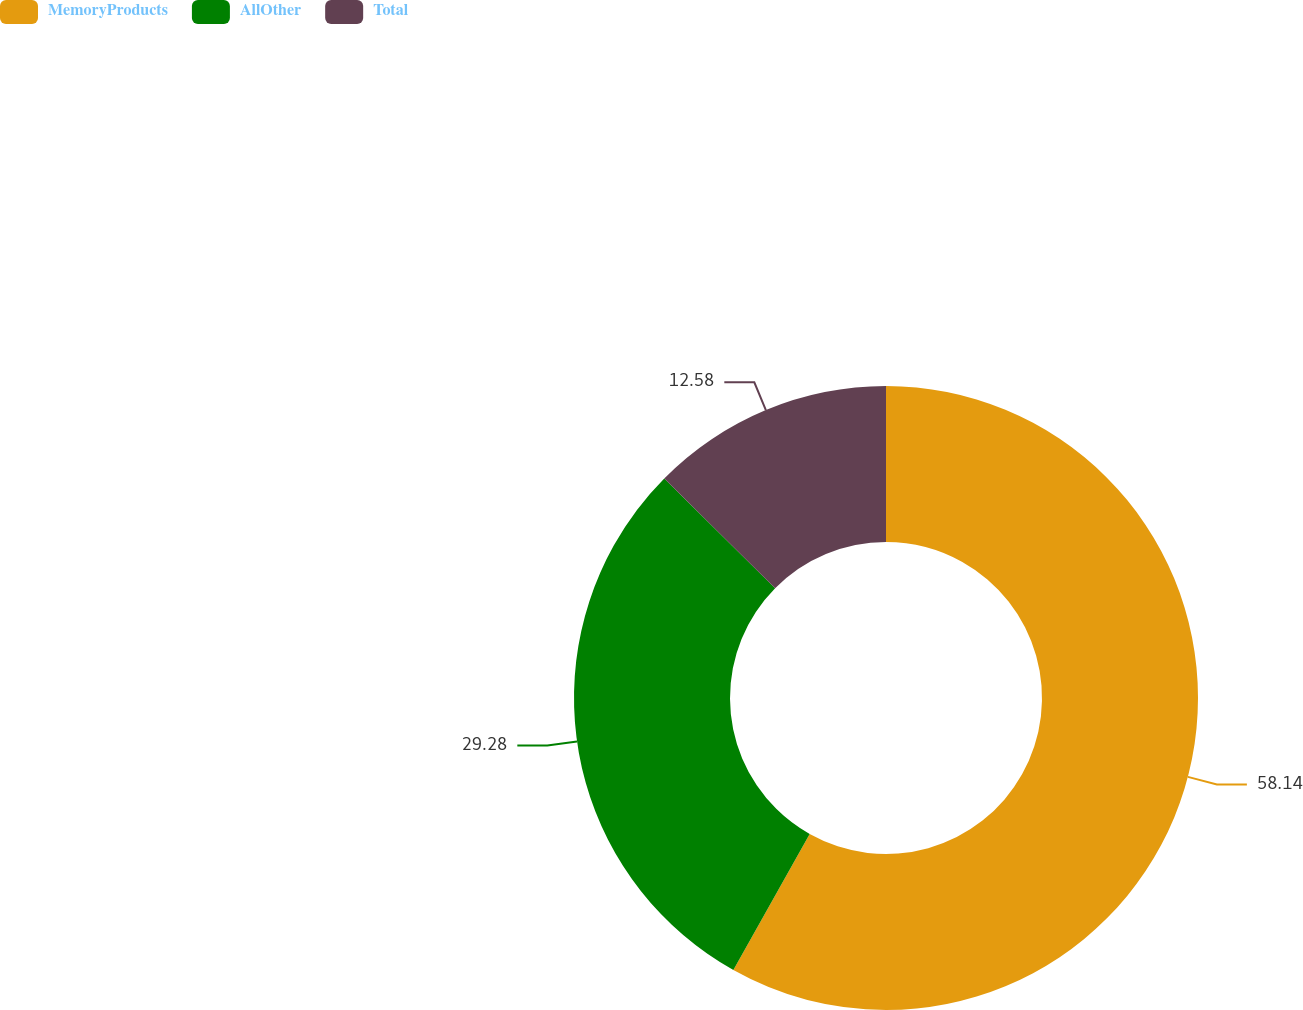Convert chart. <chart><loc_0><loc_0><loc_500><loc_500><pie_chart><fcel>MemoryProducts<fcel>AllOther<fcel>Total<nl><fcel>58.13%<fcel>29.28%<fcel>12.58%<nl></chart> 